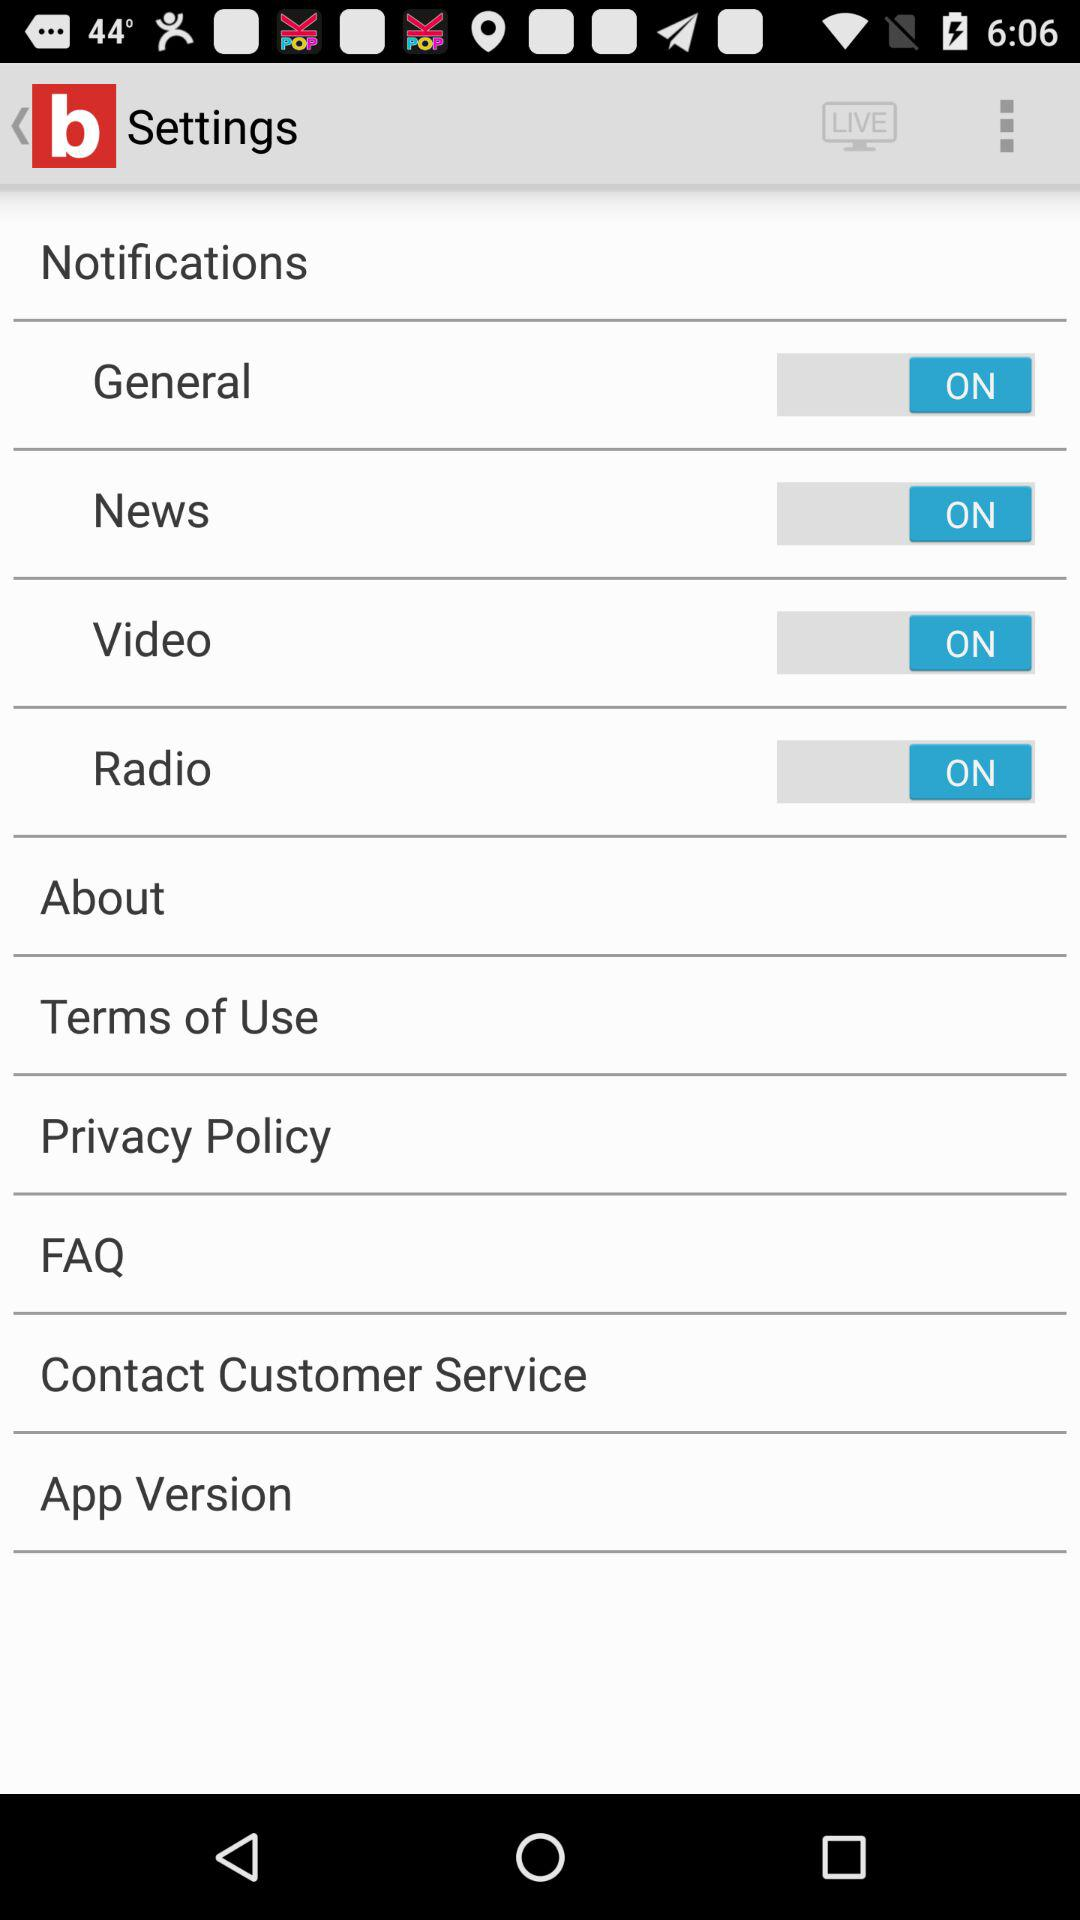What is the status of the "General" notification setting? The status is "on". 